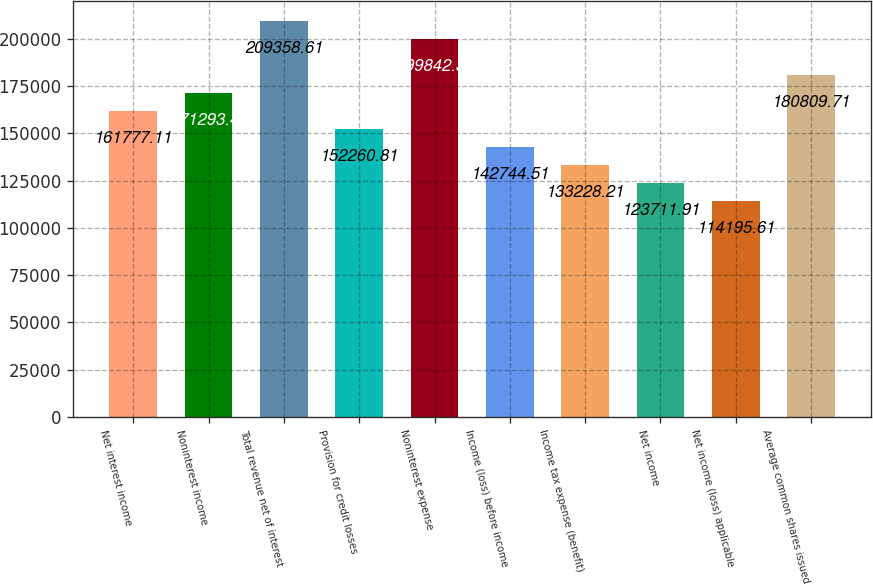Convert chart to OTSL. <chart><loc_0><loc_0><loc_500><loc_500><bar_chart><fcel>Net interest income<fcel>Noninterest income<fcel>Total revenue net of interest<fcel>Provision for credit losses<fcel>Noninterest expense<fcel>Income (loss) before income<fcel>Income tax expense (benefit)<fcel>Net income<fcel>Net income (loss) applicable<fcel>Average common shares issued<nl><fcel>161777<fcel>171293<fcel>209359<fcel>152261<fcel>199842<fcel>142745<fcel>133228<fcel>123712<fcel>114196<fcel>180810<nl></chart> 